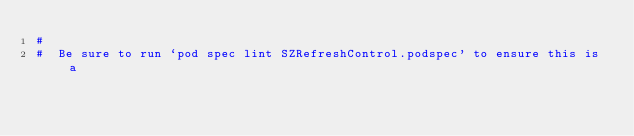Convert code to text. <code><loc_0><loc_0><loc_500><loc_500><_Ruby_>#
#  Be sure to run `pod spec lint SZRefreshControl.podspec' to ensure this is a</code> 